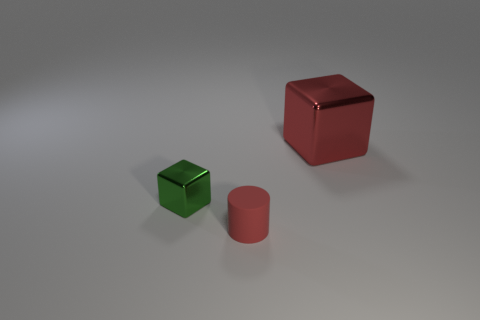Add 3 small red rubber things. How many objects exist? 6 Subtract all cylinders. How many objects are left? 2 Add 3 large red blocks. How many large red blocks exist? 4 Subtract 0 purple cylinders. How many objects are left? 3 Subtract all red cylinders. Subtract all cyan cylinders. How many objects are left? 2 Add 1 small red rubber things. How many small red rubber things are left? 2 